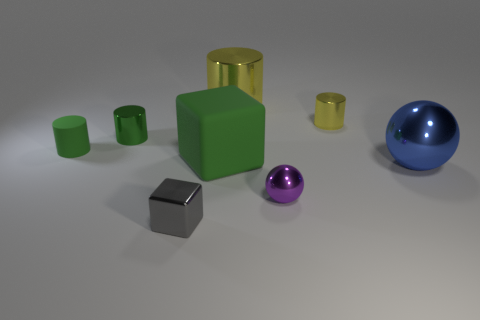Add 2 small green things. How many objects exist? 10 Subtract all balls. How many objects are left? 6 Add 5 tiny green shiny things. How many tiny green shiny things exist? 6 Subtract 1 blue balls. How many objects are left? 7 Subtract all large cylinders. Subtract all red cylinders. How many objects are left? 7 Add 8 small metal blocks. How many small metal blocks are left? 9 